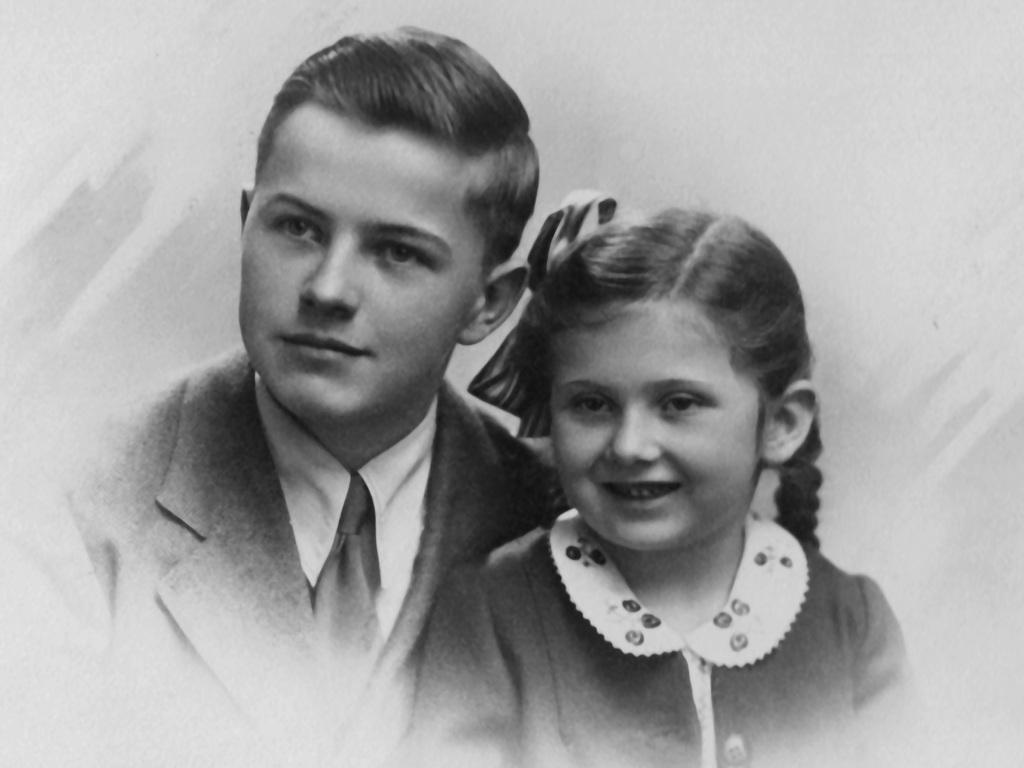How many people are in the image? There are two people in the image, a boy and a girl. What can be said about the color scheme of the image? The image is black and white. What type of ring is the writer wearing in the image? There is no writer or ring present in the image; it features a boy and a girl. 